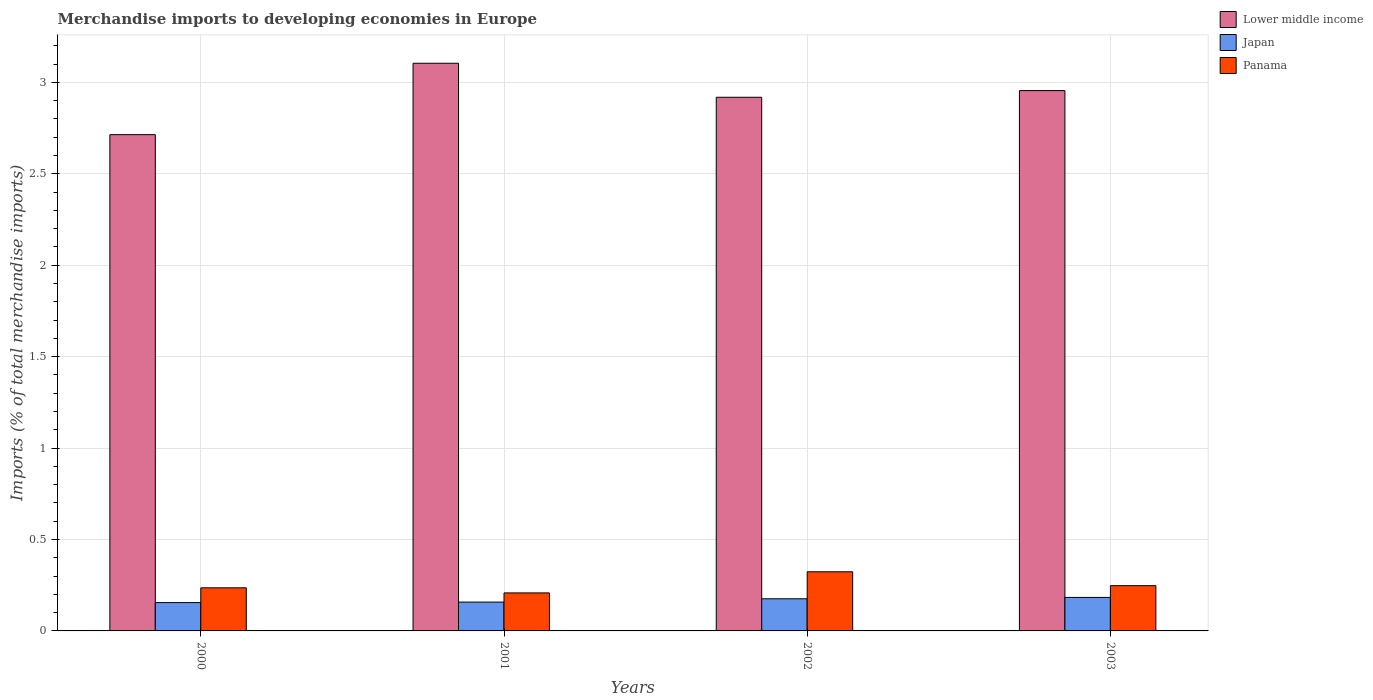How many different coloured bars are there?
Make the answer very short. 3. How many groups of bars are there?
Offer a very short reply. 4. Are the number of bars per tick equal to the number of legend labels?
Keep it short and to the point. Yes. How many bars are there on the 1st tick from the left?
Provide a succinct answer. 3. What is the percentage total merchandise imports in Japan in 2002?
Provide a succinct answer. 0.18. Across all years, what is the maximum percentage total merchandise imports in Japan?
Offer a very short reply. 0.18. Across all years, what is the minimum percentage total merchandise imports in Panama?
Make the answer very short. 0.21. What is the total percentage total merchandise imports in Panama in the graph?
Offer a very short reply. 1.01. What is the difference between the percentage total merchandise imports in Panama in 2000 and that in 2001?
Your response must be concise. 0.03. What is the difference between the percentage total merchandise imports in Japan in 2000 and the percentage total merchandise imports in Panama in 2002?
Your response must be concise. -0.17. What is the average percentage total merchandise imports in Lower middle income per year?
Offer a very short reply. 2.92. In the year 2002, what is the difference between the percentage total merchandise imports in Japan and percentage total merchandise imports in Lower middle income?
Offer a very short reply. -2.74. What is the ratio of the percentage total merchandise imports in Lower middle income in 2001 to that in 2002?
Your response must be concise. 1.06. Is the difference between the percentage total merchandise imports in Japan in 2002 and 2003 greater than the difference between the percentage total merchandise imports in Lower middle income in 2002 and 2003?
Provide a succinct answer. Yes. What is the difference between the highest and the second highest percentage total merchandise imports in Japan?
Make the answer very short. 0.01. What is the difference between the highest and the lowest percentage total merchandise imports in Lower middle income?
Provide a succinct answer. 0.39. In how many years, is the percentage total merchandise imports in Panama greater than the average percentage total merchandise imports in Panama taken over all years?
Keep it short and to the point. 1. Is the sum of the percentage total merchandise imports in Lower middle income in 2001 and 2002 greater than the maximum percentage total merchandise imports in Japan across all years?
Offer a terse response. Yes. What does the 2nd bar from the left in 2002 represents?
Offer a terse response. Japan. What does the 1st bar from the right in 2002 represents?
Provide a short and direct response. Panama. How many bars are there?
Your answer should be very brief. 12. How many years are there in the graph?
Your response must be concise. 4. Does the graph contain grids?
Provide a succinct answer. Yes. Where does the legend appear in the graph?
Offer a terse response. Top right. How many legend labels are there?
Keep it short and to the point. 3. What is the title of the graph?
Your response must be concise. Merchandise imports to developing economies in Europe. What is the label or title of the X-axis?
Your answer should be compact. Years. What is the label or title of the Y-axis?
Offer a terse response. Imports (% of total merchandise imports). What is the Imports (% of total merchandise imports) of Lower middle income in 2000?
Your answer should be very brief. 2.71. What is the Imports (% of total merchandise imports) in Japan in 2000?
Give a very brief answer. 0.15. What is the Imports (% of total merchandise imports) in Panama in 2000?
Your answer should be very brief. 0.24. What is the Imports (% of total merchandise imports) of Lower middle income in 2001?
Provide a succinct answer. 3.1. What is the Imports (% of total merchandise imports) of Japan in 2001?
Keep it short and to the point. 0.16. What is the Imports (% of total merchandise imports) of Panama in 2001?
Make the answer very short. 0.21. What is the Imports (% of total merchandise imports) of Lower middle income in 2002?
Provide a short and direct response. 2.92. What is the Imports (% of total merchandise imports) of Japan in 2002?
Your response must be concise. 0.18. What is the Imports (% of total merchandise imports) in Panama in 2002?
Provide a succinct answer. 0.32. What is the Imports (% of total merchandise imports) of Lower middle income in 2003?
Your answer should be very brief. 2.95. What is the Imports (% of total merchandise imports) of Japan in 2003?
Offer a very short reply. 0.18. What is the Imports (% of total merchandise imports) of Panama in 2003?
Your answer should be compact. 0.25. Across all years, what is the maximum Imports (% of total merchandise imports) in Lower middle income?
Offer a terse response. 3.1. Across all years, what is the maximum Imports (% of total merchandise imports) of Japan?
Offer a very short reply. 0.18. Across all years, what is the maximum Imports (% of total merchandise imports) of Panama?
Your answer should be very brief. 0.32. Across all years, what is the minimum Imports (% of total merchandise imports) in Lower middle income?
Make the answer very short. 2.71. Across all years, what is the minimum Imports (% of total merchandise imports) of Japan?
Your answer should be compact. 0.15. Across all years, what is the minimum Imports (% of total merchandise imports) of Panama?
Keep it short and to the point. 0.21. What is the total Imports (% of total merchandise imports) of Lower middle income in the graph?
Keep it short and to the point. 11.69. What is the total Imports (% of total merchandise imports) of Japan in the graph?
Provide a short and direct response. 0.67. What is the total Imports (% of total merchandise imports) in Panama in the graph?
Your answer should be compact. 1.01. What is the difference between the Imports (% of total merchandise imports) of Lower middle income in 2000 and that in 2001?
Provide a succinct answer. -0.39. What is the difference between the Imports (% of total merchandise imports) of Japan in 2000 and that in 2001?
Make the answer very short. -0. What is the difference between the Imports (% of total merchandise imports) of Panama in 2000 and that in 2001?
Offer a terse response. 0.03. What is the difference between the Imports (% of total merchandise imports) of Lower middle income in 2000 and that in 2002?
Provide a succinct answer. -0.2. What is the difference between the Imports (% of total merchandise imports) in Japan in 2000 and that in 2002?
Provide a succinct answer. -0.02. What is the difference between the Imports (% of total merchandise imports) of Panama in 2000 and that in 2002?
Your response must be concise. -0.09. What is the difference between the Imports (% of total merchandise imports) of Lower middle income in 2000 and that in 2003?
Provide a succinct answer. -0.24. What is the difference between the Imports (% of total merchandise imports) in Japan in 2000 and that in 2003?
Provide a succinct answer. -0.03. What is the difference between the Imports (% of total merchandise imports) in Panama in 2000 and that in 2003?
Your response must be concise. -0.01. What is the difference between the Imports (% of total merchandise imports) of Lower middle income in 2001 and that in 2002?
Keep it short and to the point. 0.19. What is the difference between the Imports (% of total merchandise imports) in Japan in 2001 and that in 2002?
Provide a short and direct response. -0.02. What is the difference between the Imports (% of total merchandise imports) in Panama in 2001 and that in 2002?
Offer a very short reply. -0.12. What is the difference between the Imports (% of total merchandise imports) of Lower middle income in 2001 and that in 2003?
Ensure brevity in your answer.  0.15. What is the difference between the Imports (% of total merchandise imports) in Japan in 2001 and that in 2003?
Provide a short and direct response. -0.03. What is the difference between the Imports (% of total merchandise imports) of Panama in 2001 and that in 2003?
Your answer should be very brief. -0.04. What is the difference between the Imports (% of total merchandise imports) of Lower middle income in 2002 and that in 2003?
Give a very brief answer. -0.04. What is the difference between the Imports (% of total merchandise imports) of Japan in 2002 and that in 2003?
Your answer should be very brief. -0.01. What is the difference between the Imports (% of total merchandise imports) of Panama in 2002 and that in 2003?
Your answer should be very brief. 0.08. What is the difference between the Imports (% of total merchandise imports) in Lower middle income in 2000 and the Imports (% of total merchandise imports) in Japan in 2001?
Make the answer very short. 2.56. What is the difference between the Imports (% of total merchandise imports) in Lower middle income in 2000 and the Imports (% of total merchandise imports) in Panama in 2001?
Make the answer very short. 2.51. What is the difference between the Imports (% of total merchandise imports) of Japan in 2000 and the Imports (% of total merchandise imports) of Panama in 2001?
Ensure brevity in your answer.  -0.05. What is the difference between the Imports (% of total merchandise imports) in Lower middle income in 2000 and the Imports (% of total merchandise imports) in Japan in 2002?
Your answer should be very brief. 2.54. What is the difference between the Imports (% of total merchandise imports) of Lower middle income in 2000 and the Imports (% of total merchandise imports) of Panama in 2002?
Keep it short and to the point. 2.39. What is the difference between the Imports (% of total merchandise imports) of Japan in 2000 and the Imports (% of total merchandise imports) of Panama in 2002?
Your response must be concise. -0.17. What is the difference between the Imports (% of total merchandise imports) of Lower middle income in 2000 and the Imports (% of total merchandise imports) of Japan in 2003?
Your response must be concise. 2.53. What is the difference between the Imports (% of total merchandise imports) in Lower middle income in 2000 and the Imports (% of total merchandise imports) in Panama in 2003?
Your answer should be very brief. 2.47. What is the difference between the Imports (% of total merchandise imports) of Japan in 2000 and the Imports (% of total merchandise imports) of Panama in 2003?
Keep it short and to the point. -0.09. What is the difference between the Imports (% of total merchandise imports) in Lower middle income in 2001 and the Imports (% of total merchandise imports) in Japan in 2002?
Give a very brief answer. 2.93. What is the difference between the Imports (% of total merchandise imports) of Lower middle income in 2001 and the Imports (% of total merchandise imports) of Panama in 2002?
Give a very brief answer. 2.78. What is the difference between the Imports (% of total merchandise imports) in Japan in 2001 and the Imports (% of total merchandise imports) in Panama in 2002?
Your response must be concise. -0.17. What is the difference between the Imports (% of total merchandise imports) of Lower middle income in 2001 and the Imports (% of total merchandise imports) of Japan in 2003?
Ensure brevity in your answer.  2.92. What is the difference between the Imports (% of total merchandise imports) of Lower middle income in 2001 and the Imports (% of total merchandise imports) of Panama in 2003?
Offer a very short reply. 2.86. What is the difference between the Imports (% of total merchandise imports) in Japan in 2001 and the Imports (% of total merchandise imports) in Panama in 2003?
Offer a terse response. -0.09. What is the difference between the Imports (% of total merchandise imports) of Lower middle income in 2002 and the Imports (% of total merchandise imports) of Japan in 2003?
Provide a succinct answer. 2.74. What is the difference between the Imports (% of total merchandise imports) of Lower middle income in 2002 and the Imports (% of total merchandise imports) of Panama in 2003?
Keep it short and to the point. 2.67. What is the difference between the Imports (% of total merchandise imports) in Japan in 2002 and the Imports (% of total merchandise imports) in Panama in 2003?
Keep it short and to the point. -0.07. What is the average Imports (% of total merchandise imports) of Lower middle income per year?
Give a very brief answer. 2.92. What is the average Imports (% of total merchandise imports) in Japan per year?
Your response must be concise. 0.17. What is the average Imports (% of total merchandise imports) in Panama per year?
Make the answer very short. 0.25. In the year 2000, what is the difference between the Imports (% of total merchandise imports) of Lower middle income and Imports (% of total merchandise imports) of Japan?
Offer a terse response. 2.56. In the year 2000, what is the difference between the Imports (% of total merchandise imports) of Lower middle income and Imports (% of total merchandise imports) of Panama?
Offer a very short reply. 2.48. In the year 2000, what is the difference between the Imports (% of total merchandise imports) in Japan and Imports (% of total merchandise imports) in Panama?
Your answer should be compact. -0.08. In the year 2001, what is the difference between the Imports (% of total merchandise imports) in Lower middle income and Imports (% of total merchandise imports) in Japan?
Ensure brevity in your answer.  2.95. In the year 2001, what is the difference between the Imports (% of total merchandise imports) of Lower middle income and Imports (% of total merchandise imports) of Panama?
Offer a very short reply. 2.9. In the year 2001, what is the difference between the Imports (% of total merchandise imports) of Japan and Imports (% of total merchandise imports) of Panama?
Your response must be concise. -0.05. In the year 2002, what is the difference between the Imports (% of total merchandise imports) in Lower middle income and Imports (% of total merchandise imports) in Japan?
Give a very brief answer. 2.74. In the year 2002, what is the difference between the Imports (% of total merchandise imports) of Lower middle income and Imports (% of total merchandise imports) of Panama?
Give a very brief answer. 2.6. In the year 2002, what is the difference between the Imports (% of total merchandise imports) of Japan and Imports (% of total merchandise imports) of Panama?
Offer a very short reply. -0.15. In the year 2003, what is the difference between the Imports (% of total merchandise imports) of Lower middle income and Imports (% of total merchandise imports) of Japan?
Provide a succinct answer. 2.77. In the year 2003, what is the difference between the Imports (% of total merchandise imports) in Lower middle income and Imports (% of total merchandise imports) in Panama?
Provide a short and direct response. 2.71. In the year 2003, what is the difference between the Imports (% of total merchandise imports) of Japan and Imports (% of total merchandise imports) of Panama?
Offer a terse response. -0.06. What is the ratio of the Imports (% of total merchandise imports) in Lower middle income in 2000 to that in 2001?
Provide a short and direct response. 0.87. What is the ratio of the Imports (% of total merchandise imports) of Japan in 2000 to that in 2001?
Your answer should be compact. 0.98. What is the ratio of the Imports (% of total merchandise imports) of Panama in 2000 to that in 2001?
Offer a very short reply. 1.13. What is the ratio of the Imports (% of total merchandise imports) in Japan in 2000 to that in 2002?
Make the answer very short. 0.88. What is the ratio of the Imports (% of total merchandise imports) in Panama in 2000 to that in 2002?
Offer a very short reply. 0.73. What is the ratio of the Imports (% of total merchandise imports) of Lower middle income in 2000 to that in 2003?
Offer a very short reply. 0.92. What is the ratio of the Imports (% of total merchandise imports) in Japan in 2000 to that in 2003?
Give a very brief answer. 0.85. What is the ratio of the Imports (% of total merchandise imports) in Panama in 2000 to that in 2003?
Provide a succinct answer. 0.95. What is the ratio of the Imports (% of total merchandise imports) of Lower middle income in 2001 to that in 2002?
Your answer should be compact. 1.06. What is the ratio of the Imports (% of total merchandise imports) of Japan in 2001 to that in 2002?
Your answer should be compact. 0.9. What is the ratio of the Imports (% of total merchandise imports) of Panama in 2001 to that in 2002?
Keep it short and to the point. 0.64. What is the ratio of the Imports (% of total merchandise imports) in Lower middle income in 2001 to that in 2003?
Keep it short and to the point. 1.05. What is the ratio of the Imports (% of total merchandise imports) of Japan in 2001 to that in 2003?
Ensure brevity in your answer.  0.86. What is the ratio of the Imports (% of total merchandise imports) in Panama in 2001 to that in 2003?
Your response must be concise. 0.84. What is the ratio of the Imports (% of total merchandise imports) of Lower middle income in 2002 to that in 2003?
Your answer should be compact. 0.99. What is the ratio of the Imports (% of total merchandise imports) in Japan in 2002 to that in 2003?
Provide a succinct answer. 0.96. What is the ratio of the Imports (% of total merchandise imports) in Panama in 2002 to that in 2003?
Your answer should be very brief. 1.31. What is the difference between the highest and the second highest Imports (% of total merchandise imports) in Lower middle income?
Offer a terse response. 0.15. What is the difference between the highest and the second highest Imports (% of total merchandise imports) of Japan?
Keep it short and to the point. 0.01. What is the difference between the highest and the second highest Imports (% of total merchandise imports) of Panama?
Make the answer very short. 0.08. What is the difference between the highest and the lowest Imports (% of total merchandise imports) of Lower middle income?
Ensure brevity in your answer.  0.39. What is the difference between the highest and the lowest Imports (% of total merchandise imports) in Japan?
Your response must be concise. 0.03. What is the difference between the highest and the lowest Imports (% of total merchandise imports) in Panama?
Make the answer very short. 0.12. 